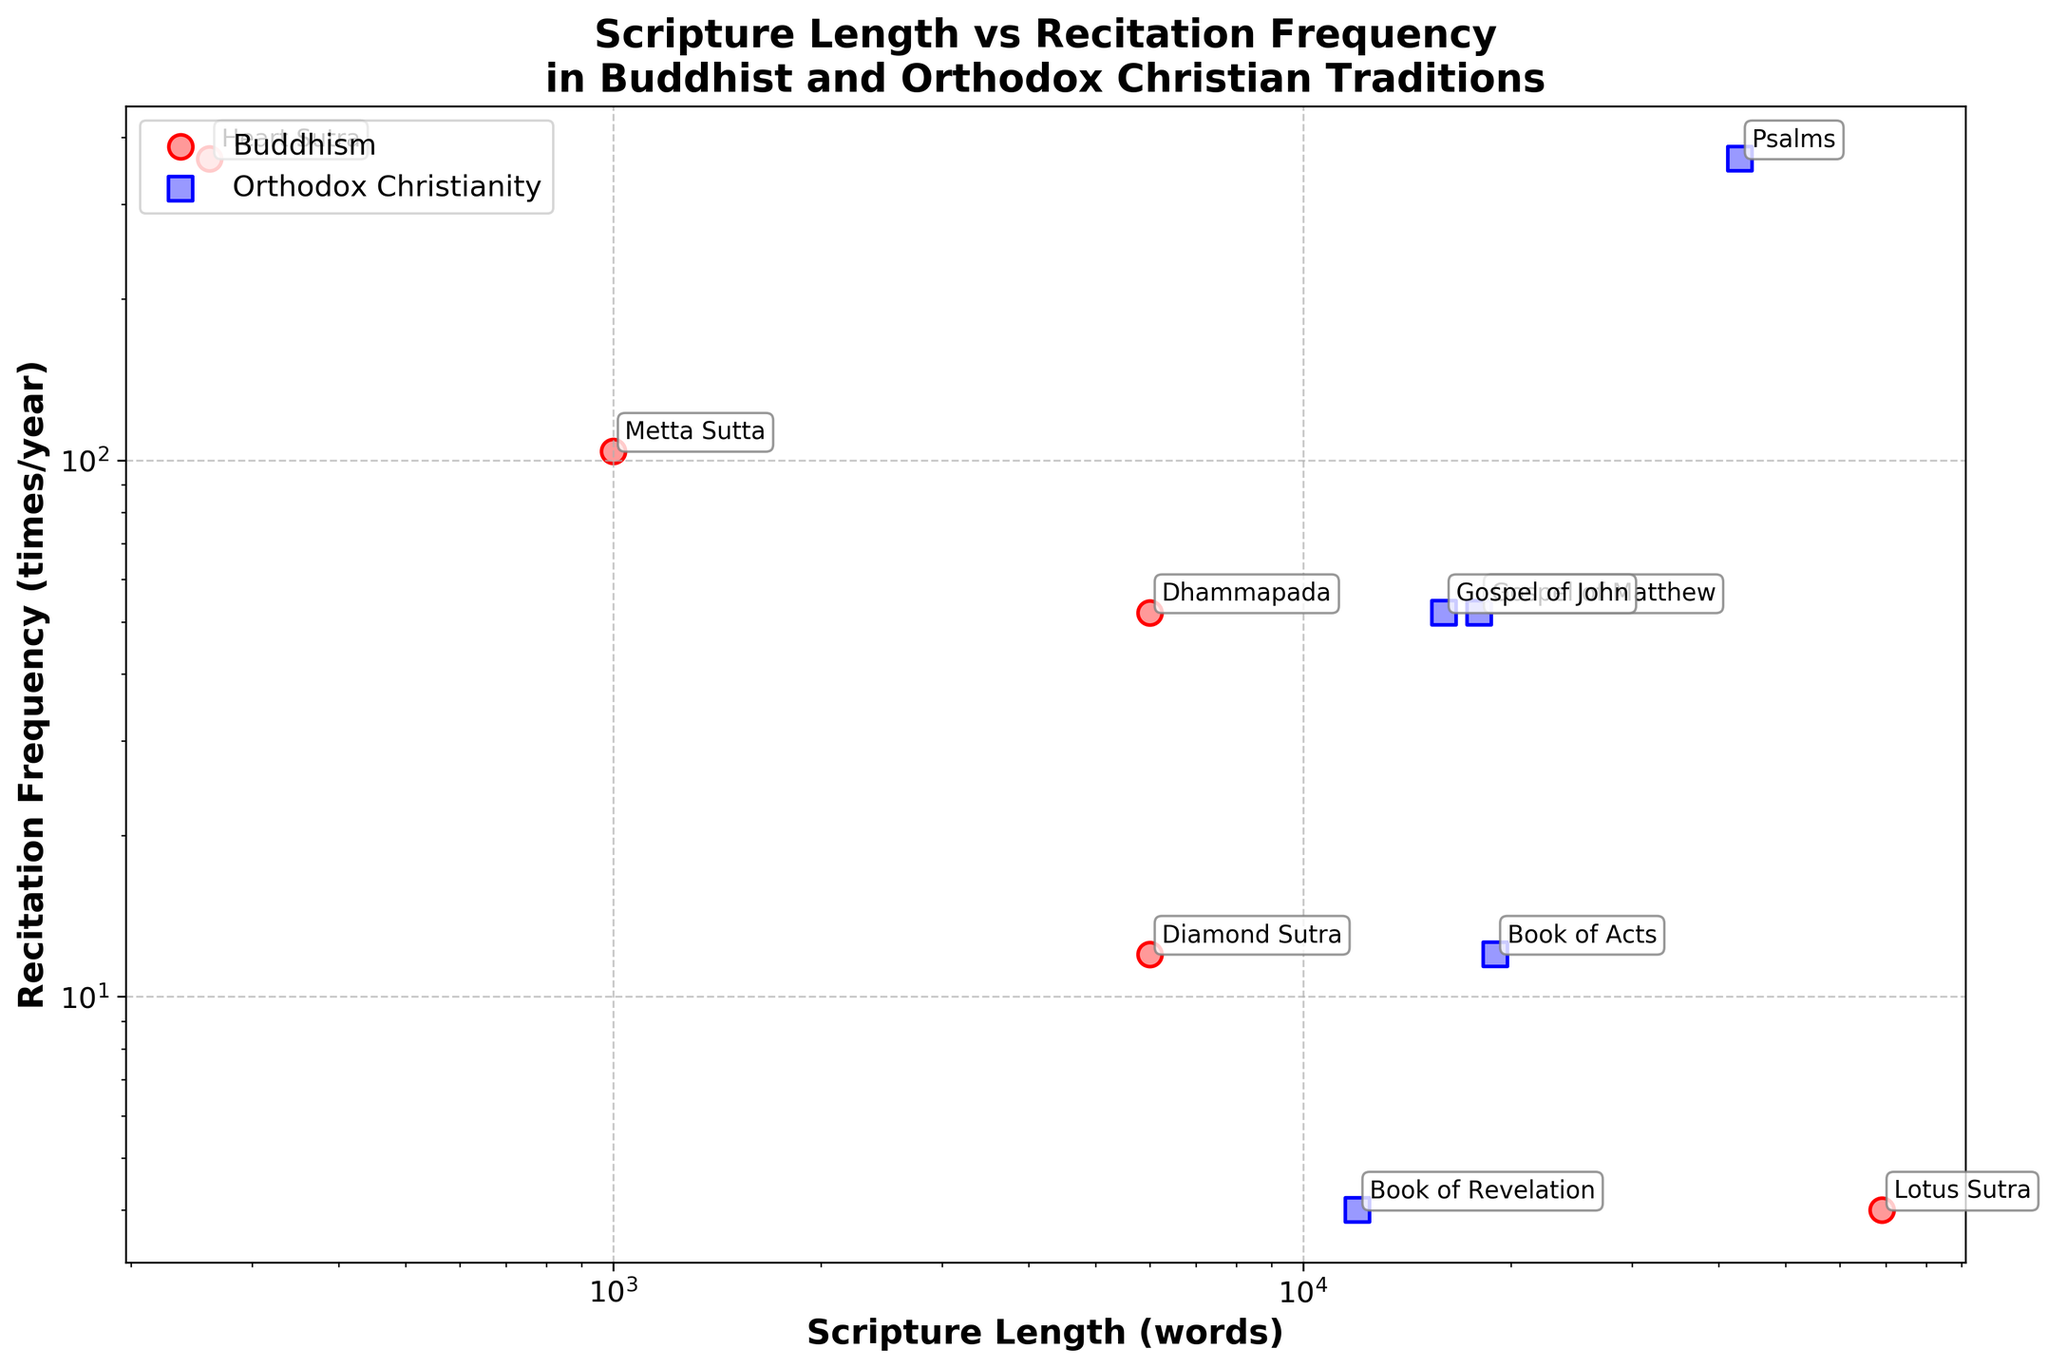What is the title of the plot? The title of the plot is a text label usually located at the top of the figure. In this case, it reads "Scripture Length vs Recitation Frequency in Buddhist and Orthodox Christian Traditions".
Answer: Scripture Length vs Recitation Frequency in Buddhist and Orthodox Christian Traditions How many scriptures are listed under each tradition in the plot? We count the number of data points associated with each tradition based on their color and shape. Buddhism has 5 scriptures with circular markers, and Orthodox Christianity has 5 scriptures with square markers.
Answer: 5 for each tradition Which scripture has the highest recitation frequency per year? By looking at the vertical position (Y-axis) of the data points, the one at the highest point represents the highest recitation frequency. The one at the top is "Psalms".
Answer: Psalms What is the length of the longest scripture from the Buddhist tradition? We identify the data points associated with Buddhism (circular markers) and look at their horizontal position (X-axis). The farthest to the right indicates the longest scripture, which is "Lotus Sutra" with 69,000 words.
Answer: 69,000 words Which tradition has the scripture with the shortest length and what is its recitation frequency? We find the data point at the most left position on the X-axis. It's a circular marker (Buddhism) representing "Heart Sutra", which has a length of 260 words. Its recitation frequency on the Y-axis is 365 times/year.
Answer: Buddhism, 365 times/year Which scripture is read 52 times a year in the Buddhist tradition and what is its length? We look for the circular marker (Buddhism) that aligns vertically at the 52 marks on the Y-axis. It corresponds to "Dhammapada", which has a length of 6,000 words.
Answer: Dhammapada, 6,000 words Which scripture from the Orthodox Christian tradition has a recitation frequency of 4 times per year and what is its length? We focus on the square markers (Orthodox Christianity) and find the one aligned at 4 on the Y-axis. It's "Book of Revelation" with a length of 12,000 words.
Answer: Book of Revelation, 12,000 words Comparing both traditions, which individual scripture has the largest length and what is its recitation frequency? By checking the horizontal positions (X-axis) of all markers, the farthest to the right is the longest scripture. "Lotus Sutra" from Buddhism has 69,000 words and a recitation frequency of 4 times/year.
Answer: Lotus Sutra, 4 times/year Which scriptures have the same recitation frequency but different lengths across both traditions? We look for scriptures at the same vertical position (Y-axis) but various horizontal positions (X-axis). Both "Dhammapada" and "Gospel of John" are read 52 times/year, with lengths of 6,000 and 16,000 words, respectively.
Answer: Dhammapada, Gospel of John (52 times/year) 